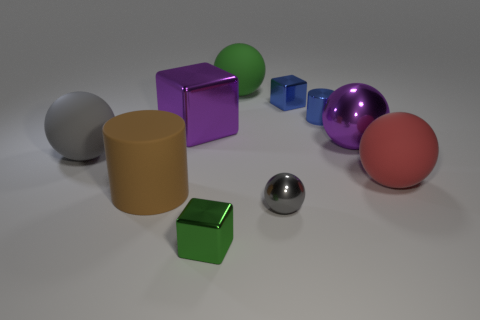There is a blue shiny thing that is the same shape as the tiny green thing; what size is it?
Make the answer very short. Small. What shape is the red rubber object?
Your answer should be very brief. Sphere. Is the material of the red sphere the same as the cylinder behind the big purple block?
Offer a very short reply. No. How many metal things are large red spheres or small gray cubes?
Offer a very short reply. 0. What is the size of the green thing behind the small blue cylinder?
Your response must be concise. Large. What size is the gray sphere that is the same material as the brown object?
Your answer should be very brief. Large. What number of other large shiny blocks have the same color as the big block?
Offer a terse response. 0. Are there any large brown things?
Provide a short and direct response. Yes. Do the large gray object and the green thing behind the large gray object have the same shape?
Offer a very short reply. Yes. What color is the big matte object that is to the right of the gray ball that is in front of the large rubber ball that is on the left side of the big brown rubber thing?
Provide a succinct answer. Red. 